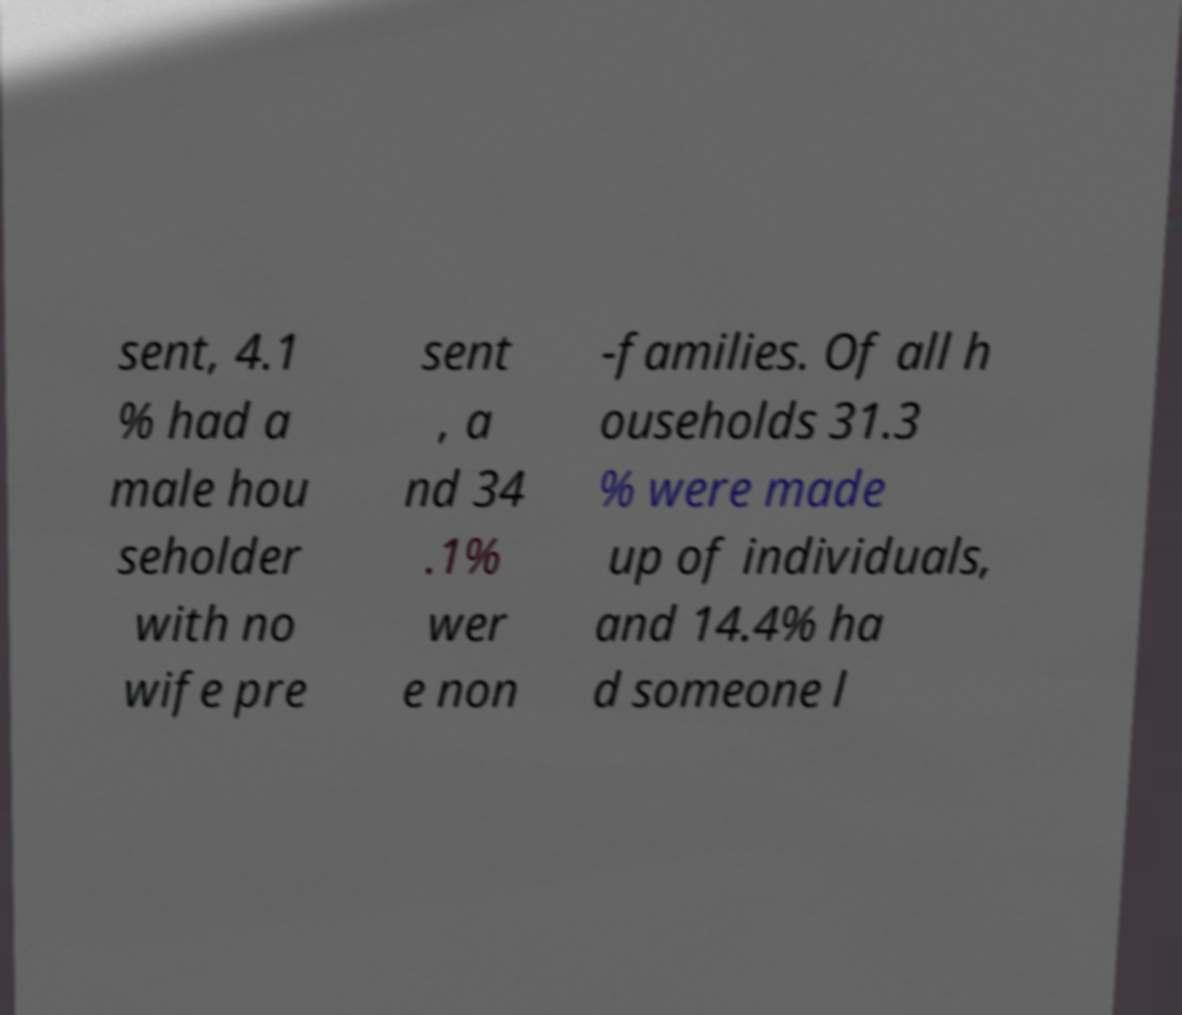Can you read and provide the text displayed in the image?This photo seems to have some interesting text. Can you extract and type it out for me? sent, 4.1 % had a male hou seholder with no wife pre sent , a nd 34 .1% wer e non -families. Of all h ouseholds 31.3 % were made up of individuals, and 14.4% ha d someone l 